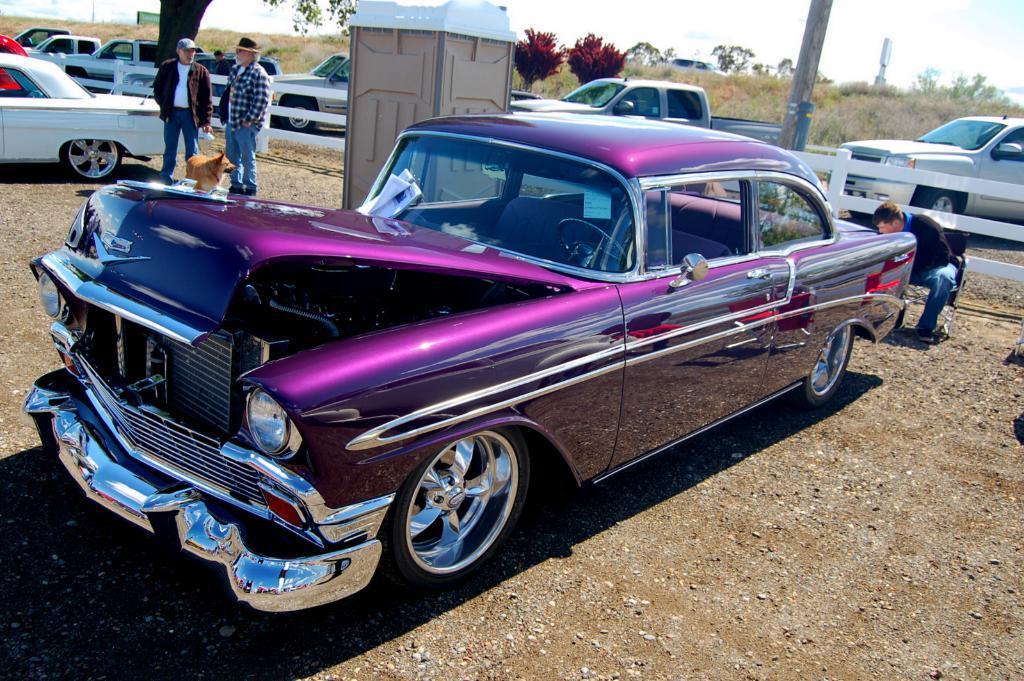Please provide a concise description of this image. This is outside view. Here I can see many cars on the ground. On the right side there is a man sitting on the chair and looking at the downwards. On the left side there are two men standing and also there is a dog. In the background, I can see many plants and trees. At the top, I can see the sky. 